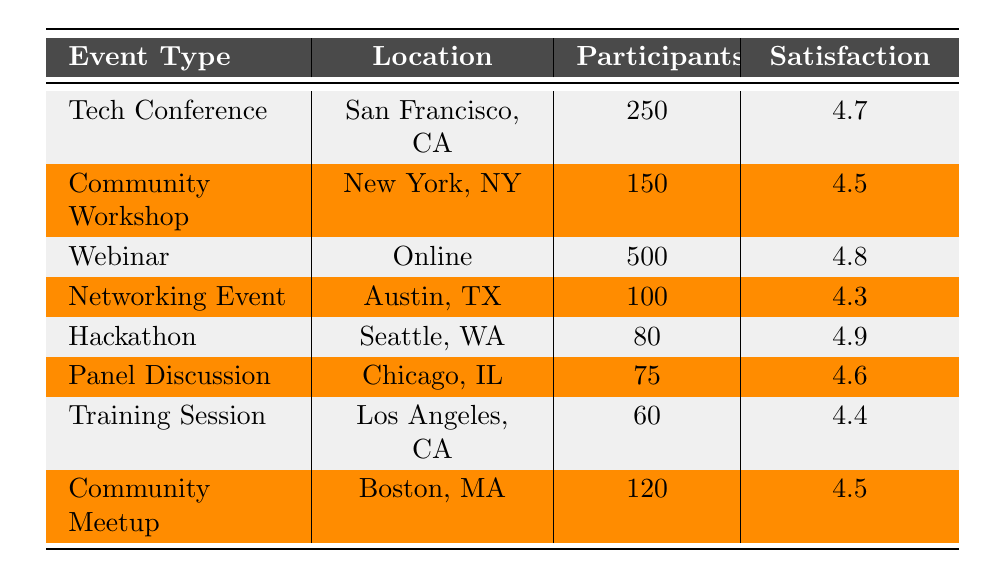What is the total number of participants across all events? To find the total number of participants, we sum the participants from each event type: 250 (Tech Conference) + 150 (Community Workshop) + 500 (Webinar) + 100 (Networking Event) + 80 (Hackathon) + 75 (Panel Discussion) + 60 (Training Session) + 120 (Community Meetup) = 1315.
Answer: 1315 Which event type had the highest satisfaction rating? The satisfaction ratings for each event type are as follows: Tech Conference (4.7), Community Workshop (4.5), Webinar (4.8), Networking Event (4.3), Hackathon (4.9), Panel Discussion (4.6), Training Session (4.4), and Community Meetup (4.5). The highest rating is 4.9 for the Hackathon.
Answer: Hackathon Is the overall average satisfaction rating above 4.5? To find the average satisfaction rating, we add all the ratings: 4.7 + 4.5 + 4.8 + 4.3 + 4.9 + 4.6 + 4.4 + 4.5 = 36.7. There are 8 events, so we divide 36.7 by 8, resulting in 4.5875, which is greater than 4.5.
Answer: Yes How many events had fewer than 100 participants? By examining the table, we see that only the Hackathon (80 participants), Panel Discussion (75 participants), and Training Session (60 participants) had fewer than 100 participants. The total count is 3.
Answer: 3 What is the difference in satisfaction ratings between the most and least satisfied events? The most satisfied event is the Hackathon with a rating of 4.9, and the least satisfied event is the Networking Event with a rating of 4.3. The difference is 4.9 - 4.3 = 0.6.
Answer: 0.6 